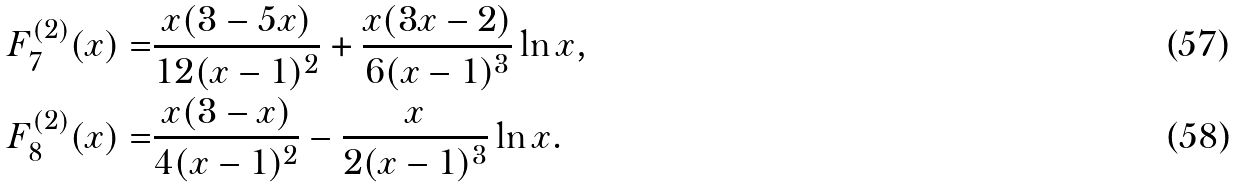Convert formula to latex. <formula><loc_0><loc_0><loc_500><loc_500>F _ { 7 } ^ { ( 2 ) } ( x ) = & \frac { x ( 3 - 5 x ) } { 1 2 ( x - 1 ) ^ { 2 } } + \frac { x ( 3 x - 2 ) } { 6 ( x - 1 ) ^ { 3 } } \ln x , \\ F _ { 8 } ^ { ( 2 ) } ( x ) = & \frac { x ( 3 - x ) } { 4 ( x - 1 ) ^ { 2 } } - \frac { x } { 2 ( x - 1 ) ^ { 3 } } \ln x .</formula> 